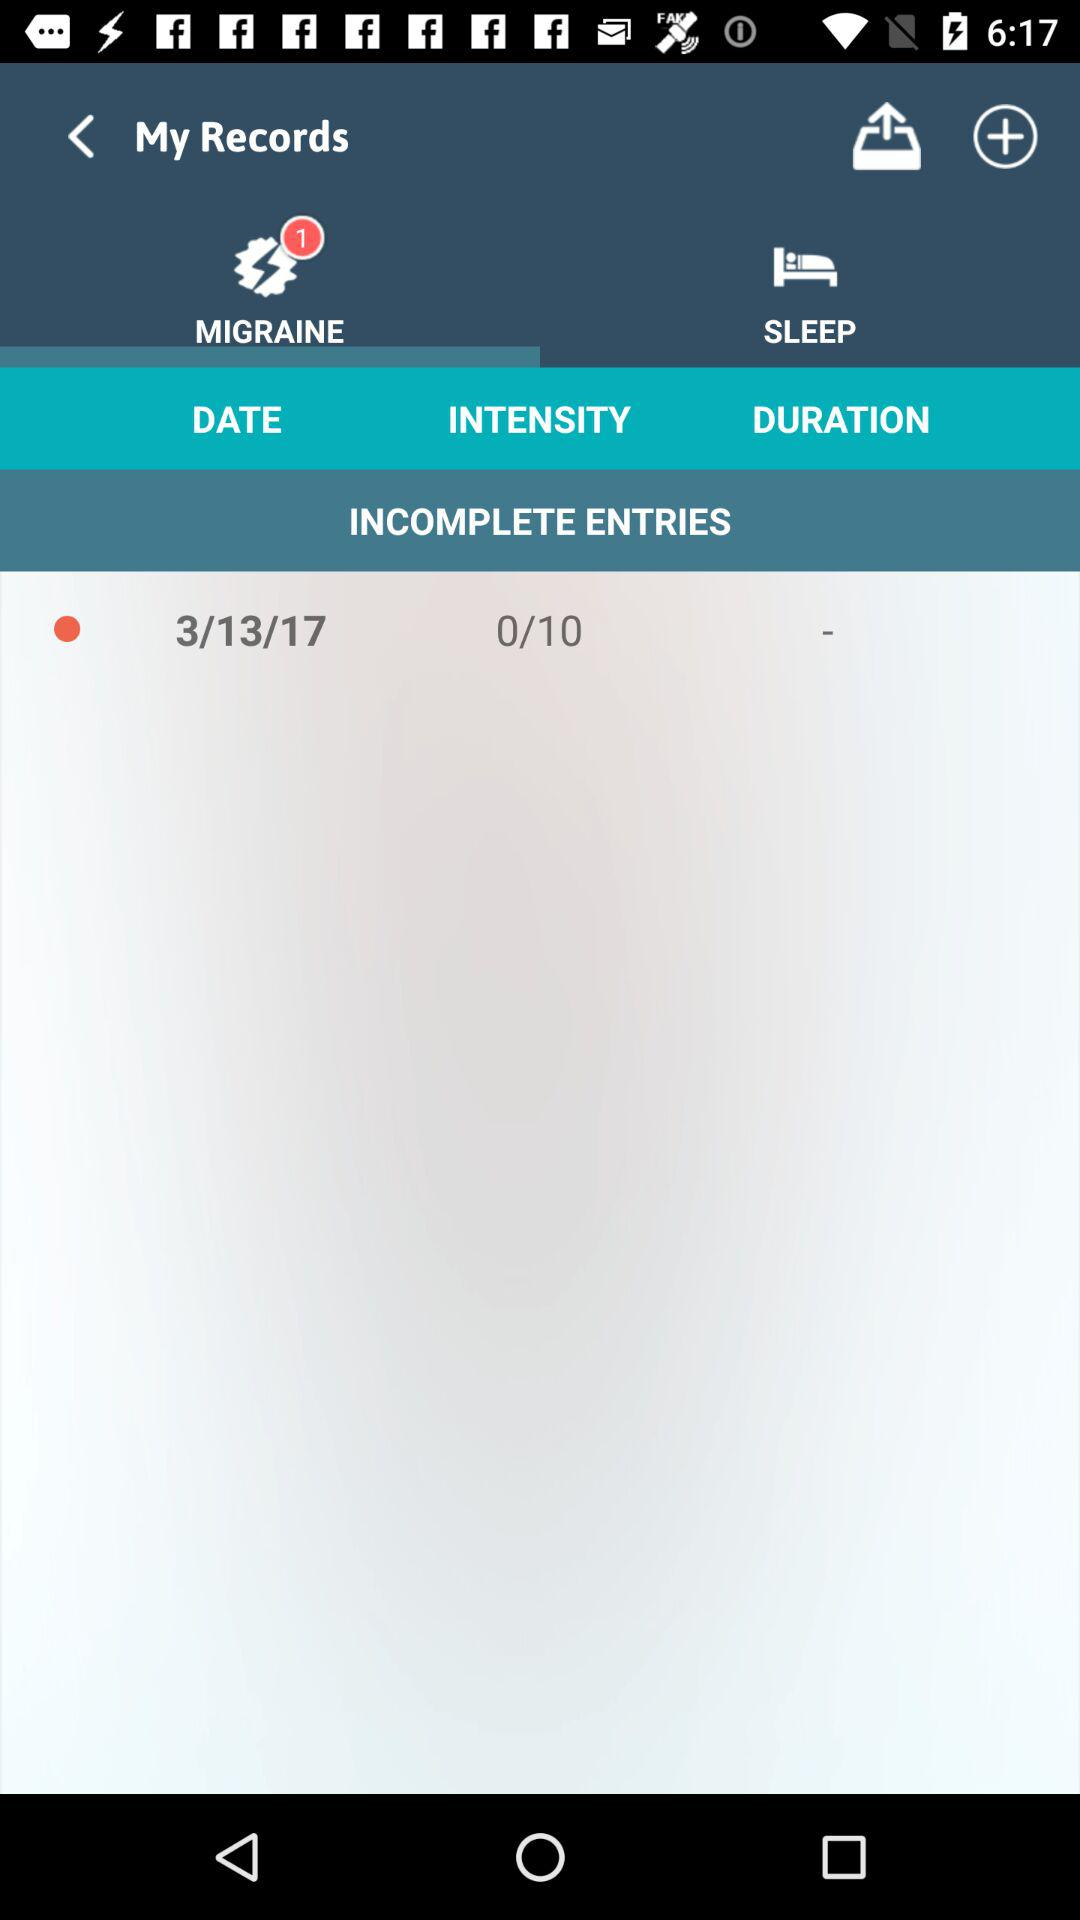How long is the duration of sleep?
When the provided information is insufficient, respond with <no answer>. <no answer> 